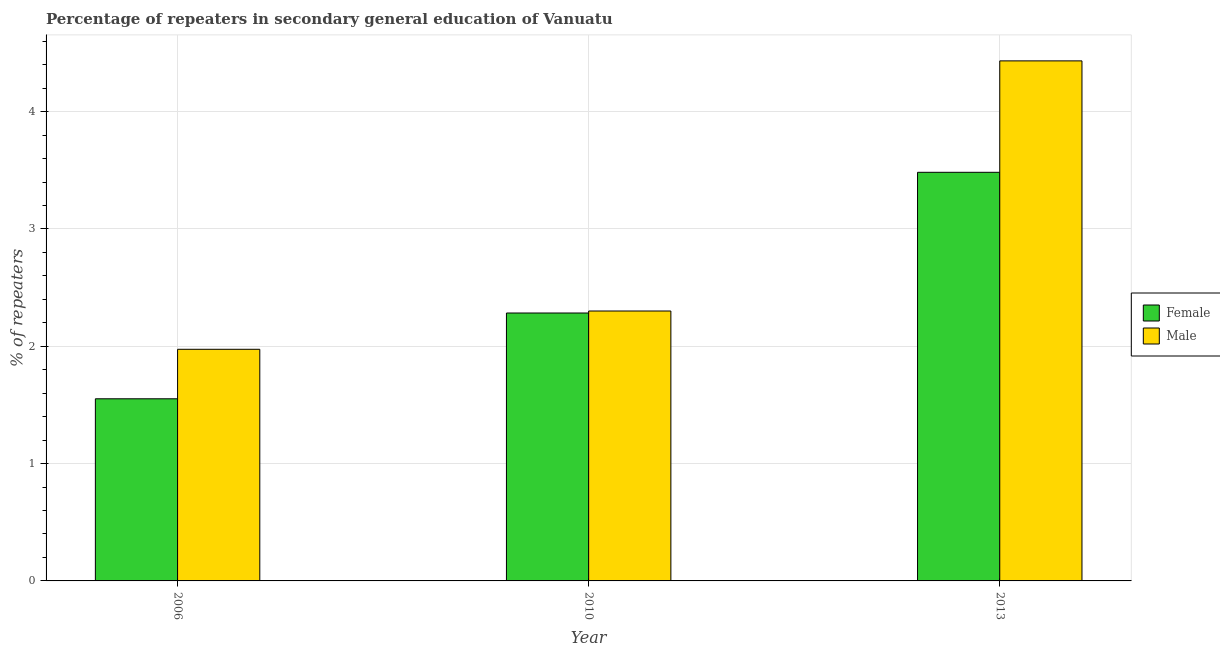Are the number of bars per tick equal to the number of legend labels?
Your response must be concise. Yes. How many bars are there on the 1st tick from the right?
Give a very brief answer. 2. What is the label of the 1st group of bars from the left?
Offer a very short reply. 2006. In how many cases, is the number of bars for a given year not equal to the number of legend labels?
Offer a terse response. 0. What is the percentage of female repeaters in 2006?
Your response must be concise. 1.55. Across all years, what is the maximum percentage of female repeaters?
Give a very brief answer. 3.48. Across all years, what is the minimum percentage of female repeaters?
Provide a short and direct response. 1.55. In which year was the percentage of male repeaters maximum?
Give a very brief answer. 2013. What is the total percentage of male repeaters in the graph?
Your answer should be compact. 8.71. What is the difference between the percentage of female repeaters in 2006 and that in 2010?
Provide a succinct answer. -0.73. What is the difference between the percentage of male repeaters in 2013 and the percentage of female repeaters in 2010?
Offer a terse response. 2.13. What is the average percentage of female repeaters per year?
Give a very brief answer. 2.44. What is the ratio of the percentage of female repeaters in 2006 to that in 2013?
Keep it short and to the point. 0.45. What is the difference between the highest and the second highest percentage of male repeaters?
Give a very brief answer. 2.13. What is the difference between the highest and the lowest percentage of female repeaters?
Offer a very short reply. 1.93. In how many years, is the percentage of female repeaters greater than the average percentage of female repeaters taken over all years?
Your answer should be compact. 1. Is the sum of the percentage of female repeaters in 2010 and 2013 greater than the maximum percentage of male repeaters across all years?
Provide a succinct answer. Yes. What does the 1st bar from the right in 2010 represents?
Your response must be concise. Male. How many bars are there?
Give a very brief answer. 6. How many years are there in the graph?
Make the answer very short. 3. What is the difference between two consecutive major ticks on the Y-axis?
Give a very brief answer. 1. Are the values on the major ticks of Y-axis written in scientific E-notation?
Your answer should be very brief. No. How are the legend labels stacked?
Provide a succinct answer. Vertical. What is the title of the graph?
Keep it short and to the point. Percentage of repeaters in secondary general education of Vanuatu. What is the label or title of the Y-axis?
Ensure brevity in your answer.  % of repeaters. What is the % of repeaters in Female in 2006?
Offer a terse response. 1.55. What is the % of repeaters in Male in 2006?
Make the answer very short. 1.97. What is the % of repeaters of Female in 2010?
Offer a terse response. 2.28. What is the % of repeaters in Male in 2010?
Offer a terse response. 2.3. What is the % of repeaters in Female in 2013?
Keep it short and to the point. 3.48. What is the % of repeaters in Male in 2013?
Make the answer very short. 4.43. Across all years, what is the maximum % of repeaters in Female?
Keep it short and to the point. 3.48. Across all years, what is the maximum % of repeaters of Male?
Your answer should be compact. 4.43. Across all years, what is the minimum % of repeaters in Female?
Your response must be concise. 1.55. Across all years, what is the minimum % of repeaters in Male?
Ensure brevity in your answer.  1.97. What is the total % of repeaters in Female in the graph?
Ensure brevity in your answer.  7.32. What is the total % of repeaters of Male in the graph?
Ensure brevity in your answer.  8.71. What is the difference between the % of repeaters of Female in 2006 and that in 2010?
Give a very brief answer. -0.73. What is the difference between the % of repeaters in Male in 2006 and that in 2010?
Provide a succinct answer. -0.33. What is the difference between the % of repeaters of Female in 2006 and that in 2013?
Give a very brief answer. -1.93. What is the difference between the % of repeaters in Male in 2006 and that in 2013?
Your response must be concise. -2.46. What is the difference between the % of repeaters in Female in 2010 and that in 2013?
Give a very brief answer. -1.2. What is the difference between the % of repeaters in Male in 2010 and that in 2013?
Offer a very short reply. -2.13. What is the difference between the % of repeaters of Female in 2006 and the % of repeaters of Male in 2010?
Offer a very short reply. -0.75. What is the difference between the % of repeaters of Female in 2006 and the % of repeaters of Male in 2013?
Offer a very short reply. -2.88. What is the difference between the % of repeaters of Female in 2010 and the % of repeaters of Male in 2013?
Offer a terse response. -2.15. What is the average % of repeaters of Female per year?
Offer a very short reply. 2.44. What is the average % of repeaters of Male per year?
Offer a terse response. 2.9. In the year 2006, what is the difference between the % of repeaters in Female and % of repeaters in Male?
Your response must be concise. -0.42. In the year 2010, what is the difference between the % of repeaters of Female and % of repeaters of Male?
Your answer should be very brief. -0.02. In the year 2013, what is the difference between the % of repeaters of Female and % of repeaters of Male?
Make the answer very short. -0.95. What is the ratio of the % of repeaters in Female in 2006 to that in 2010?
Your answer should be compact. 0.68. What is the ratio of the % of repeaters of Male in 2006 to that in 2010?
Offer a terse response. 0.86. What is the ratio of the % of repeaters of Female in 2006 to that in 2013?
Offer a very short reply. 0.45. What is the ratio of the % of repeaters of Male in 2006 to that in 2013?
Ensure brevity in your answer.  0.45. What is the ratio of the % of repeaters in Female in 2010 to that in 2013?
Give a very brief answer. 0.66. What is the ratio of the % of repeaters of Male in 2010 to that in 2013?
Provide a short and direct response. 0.52. What is the difference between the highest and the second highest % of repeaters of Female?
Make the answer very short. 1.2. What is the difference between the highest and the second highest % of repeaters of Male?
Provide a short and direct response. 2.13. What is the difference between the highest and the lowest % of repeaters of Female?
Your answer should be very brief. 1.93. What is the difference between the highest and the lowest % of repeaters of Male?
Provide a succinct answer. 2.46. 